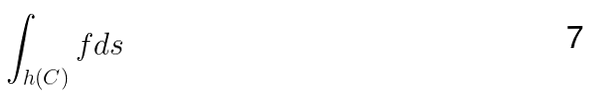Convert formula to latex. <formula><loc_0><loc_0><loc_500><loc_500>\int _ { h ( C ) } f d s</formula> 